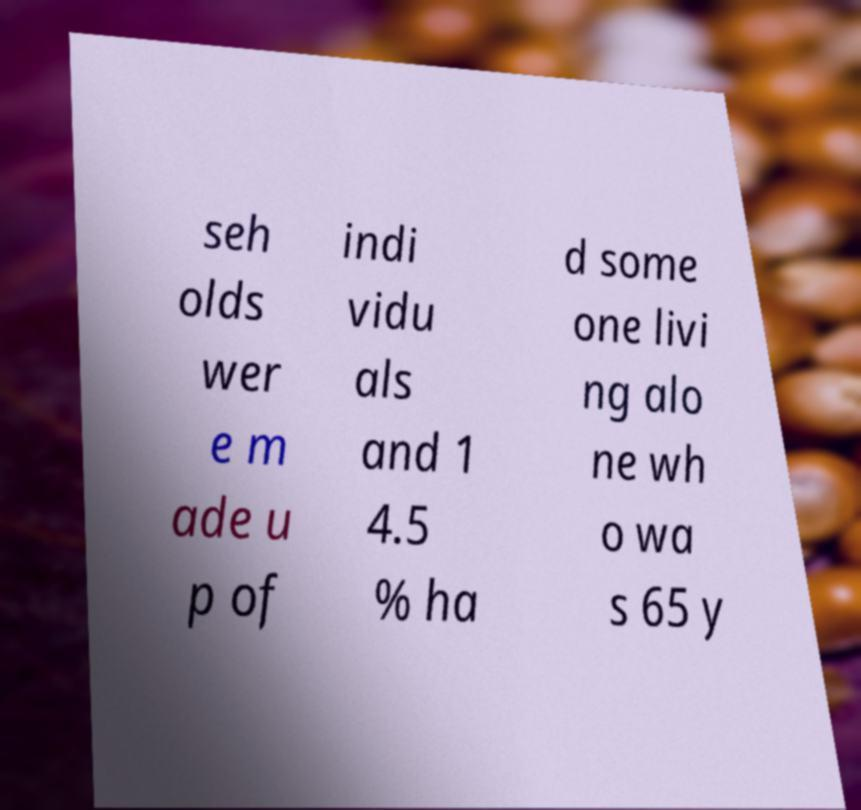There's text embedded in this image that I need extracted. Can you transcribe it verbatim? seh olds wer e m ade u p of indi vidu als and 1 4.5 % ha d some one livi ng alo ne wh o wa s 65 y 